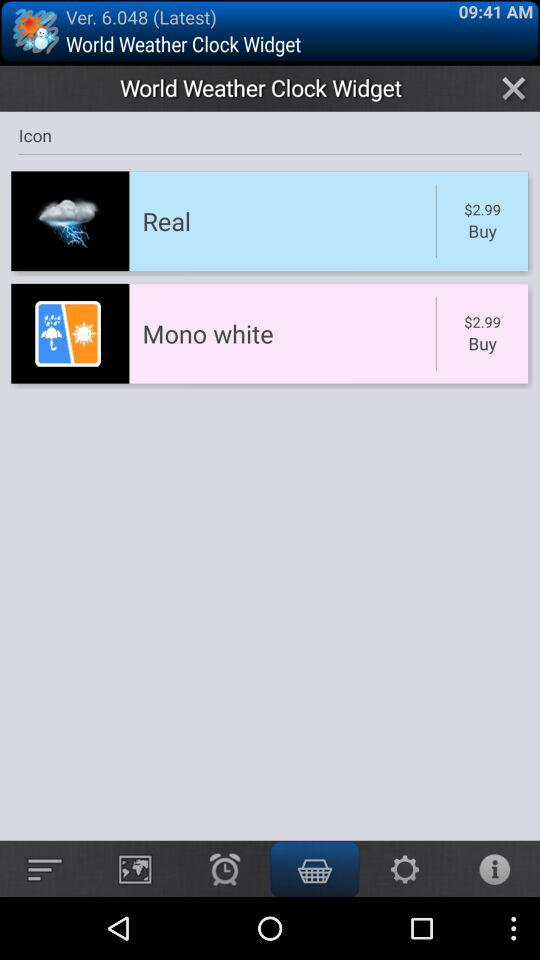What is the price of "Real" in the "World Weather Clock Widget"? The price of "Real" in the "World Weather Clock Widget" is $2.99. 